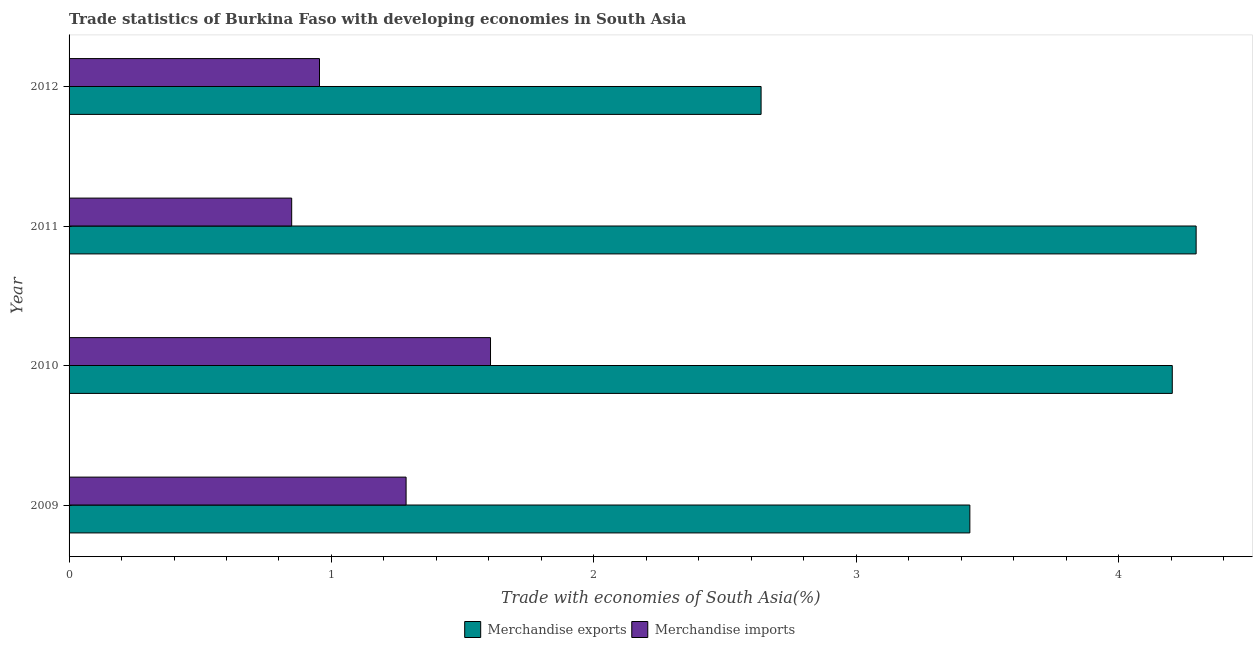How many groups of bars are there?
Offer a very short reply. 4. Are the number of bars per tick equal to the number of legend labels?
Keep it short and to the point. Yes. Are the number of bars on each tick of the Y-axis equal?
Offer a terse response. Yes. How many bars are there on the 1st tick from the top?
Ensure brevity in your answer.  2. What is the label of the 3rd group of bars from the top?
Offer a terse response. 2010. In how many cases, is the number of bars for a given year not equal to the number of legend labels?
Provide a short and direct response. 0. What is the merchandise imports in 2010?
Your answer should be compact. 1.61. Across all years, what is the maximum merchandise exports?
Offer a very short reply. 4.3. Across all years, what is the minimum merchandise imports?
Give a very brief answer. 0.85. In which year was the merchandise exports maximum?
Your answer should be compact. 2011. What is the total merchandise exports in the graph?
Your response must be concise. 14.57. What is the difference between the merchandise imports in 2009 and that in 2010?
Make the answer very short. -0.32. What is the difference between the merchandise imports in 2010 and the merchandise exports in 2011?
Provide a succinct answer. -2.69. What is the average merchandise imports per year?
Make the answer very short. 1.17. In the year 2012, what is the difference between the merchandise imports and merchandise exports?
Provide a succinct answer. -1.68. What is the ratio of the merchandise exports in 2009 to that in 2011?
Ensure brevity in your answer.  0.8. What is the difference between the highest and the second highest merchandise exports?
Your answer should be very brief. 0.09. What is the difference between the highest and the lowest merchandise exports?
Keep it short and to the point. 1.66. In how many years, is the merchandise exports greater than the average merchandise exports taken over all years?
Your answer should be compact. 2. What does the 1st bar from the bottom in 2010 represents?
Ensure brevity in your answer.  Merchandise exports. How many bars are there?
Offer a very short reply. 8. Are all the bars in the graph horizontal?
Make the answer very short. Yes. How many years are there in the graph?
Provide a short and direct response. 4. Does the graph contain any zero values?
Make the answer very short. No. What is the title of the graph?
Provide a succinct answer. Trade statistics of Burkina Faso with developing economies in South Asia. Does "Sanitation services" appear as one of the legend labels in the graph?
Your answer should be very brief. No. What is the label or title of the X-axis?
Provide a succinct answer. Trade with economies of South Asia(%). What is the Trade with economies of South Asia(%) in Merchandise exports in 2009?
Offer a terse response. 3.43. What is the Trade with economies of South Asia(%) of Merchandise imports in 2009?
Your response must be concise. 1.28. What is the Trade with economies of South Asia(%) of Merchandise exports in 2010?
Provide a short and direct response. 4.2. What is the Trade with economies of South Asia(%) of Merchandise imports in 2010?
Offer a very short reply. 1.61. What is the Trade with economies of South Asia(%) in Merchandise exports in 2011?
Provide a succinct answer. 4.3. What is the Trade with economies of South Asia(%) of Merchandise imports in 2011?
Your response must be concise. 0.85. What is the Trade with economies of South Asia(%) of Merchandise exports in 2012?
Ensure brevity in your answer.  2.64. What is the Trade with economies of South Asia(%) in Merchandise imports in 2012?
Keep it short and to the point. 0.95. Across all years, what is the maximum Trade with economies of South Asia(%) in Merchandise exports?
Your answer should be very brief. 4.3. Across all years, what is the maximum Trade with economies of South Asia(%) in Merchandise imports?
Your answer should be compact. 1.61. Across all years, what is the minimum Trade with economies of South Asia(%) of Merchandise exports?
Give a very brief answer. 2.64. Across all years, what is the minimum Trade with economies of South Asia(%) in Merchandise imports?
Offer a terse response. 0.85. What is the total Trade with economies of South Asia(%) in Merchandise exports in the graph?
Give a very brief answer. 14.57. What is the total Trade with economies of South Asia(%) of Merchandise imports in the graph?
Keep it short and to the point. 4.69. What is the difference between the Trade with economies of South Asia(%) in Merchandise exports in 2009 and that in 2010?
Offer a terse response. -0.77. What is the difference between the Trade with economies of South Asia(%) of Merchandise imports in 2009 and that in 2010?
Offer a very short reply. -0.32. What is the difference between the Trade with economies of South Asia(%) of Merchandise exports in 2009 and that in 2011?
Your answer should be very brief. -0.86. What is the difference between the Trade with economies of South Asia(%) of Merchandise imports in 2009 and that in 2011?
Ensure brevity in your answer.  0.44. What is the difference between the Trade with economies of South Asia(%) in Merchandise exports in 2009 and that in 2012?
Ensure brevity in your answer.  0.8. What is the difference between the Trade with economies of South Asia(%) of Merchandise imports in 2009 and that in 2012?
Ensure brevity in your answer.  0.33. What is the difference between the Trade with economies of South Asia(%) of Merchandise exports in 2010 and that in 2011?
Your response must be concise. -0.09. What is the difference between the Trade with economies of South Asia(%) of Merchandise imports in 2010 and that in 2011?
Ensure brevity in your answer.  0.76. What is the difference between the Trade with economies of South Asia(%) in Merchandise exports in 2010 and that in 2012?
Ensure brevity in your answer.  1.57. What is the difference between the Trade with economies of South Asia(%) of Merchandise imports in 2010 and that in 2012?
Ensure brevity in your answer.  0.65. What is the difference between the Trade with economies of South Asia(%) in Merchandise exports in 2011 and that in 2012?
Your answer should be very brief. 1.66. What is the difference between the Trade with economies of South Asia(%) of Merchandise imports in 2011 and that in 2012?
Your response must be concise. -0.11. What is the difference between the Trade with economies of South Asia(%) of Merchandise exports in 2009 and the Trade with economies of South Asia(%) of Merchandise imports in 2010?
Your answer should be very brief. 1.83. What is the difference between the Trade with economies of South Asia(%) in Merchandise exports in 2009 and the Trade with economies of South Asia(%) in Merchandise imports in 2011?
Offer a terse response. 2.58. What is the difference between the Trade with economies of South Asia(%) of Merchandise exports in 2009 and the Trade with economies of South Asia(%) of Merchandise imports in 2012?
Provide a succinct answer. 2.48. What is the difference between the Trade with economies of South Asia(%) in Merchandise exports in 2010 and the Trade with economies of South Asia(%) in Merchandise imports in 2011?
Keep it short and to the point. 3.36. What is the difference between the Trade with economies of South Asia(%) in Merchandise exports in 2010 and the Trade with economies of South Asia(%) in Merchandise imports in 2012?
Keep it short and to the point. 3.25. What is the difference between the Trade with economies of South Asia(%) in Merchandise exports in 2011 and the Trade with economies of South Asia(%) in Merchandise imports in 2012?
Make the answer very short. 3.34. What is the average Trade with economies of South Asia(%) of Merchandise exports per year?
Offer a very short reply. 3.64. What is the average Trade with economies of South Asia(%) of Merchandise imports per year?
Keep it short and to the point. 1.17. In the year 2009, what is the difference between the Trade with economies of South Asia(%) of Merchandise exports and Trade with economies of South Asia(%) of Merchandise imports?
Give a very brief answer. 2.15. In the year 2010, what is the difference between the Trade with economies of South Asia(%) in Merchandise exports and Trade with economies of South Asia(%) in Merchandise imports?
Ensure brevity in your answer.  2.6. In the year 2011, what is the difference between the Trade with economies of South Asia(%) in Merchandise exports and Trade with economies of South Asia(%) in Merchandise imports?
Offer a very short reply. 3.45. In the year 2012, what is the difference between the Trade with economies of South Asia(%) in Merchandise exports and Trade with economies of South Asia(%) in Merchandise imports?
Ensure brevity in your answer.  1.68. What is the ratio of the Trade with economies of South Asia(%) in Merchandise exports in 2009 to that in 2010?
Offer a very short reply. 0.82. What is the ratio of the Trade with economies of South Asia(%) in Merchandise imports in 2009 to that in 2010?
Offer a terse response. 0.8. What is the ratio of the Trade with economies of South Asia(%) in Merchandise exports in 2009 to that in 2011?
Provide a short and direct response. 0.8. What is the ratio of the Trade with economies of South Asia(%) in Merchandise imports in 2009 to that in 2011?
Your response must be concise. 1.51. What is the ratio of the Trade with economies of South Asia(%) of Merchandise exports in 2009 to that in 2012?
Your answer should be very brief. 1.3. What is the ratio of the Trade with economies of South Asia(%) of Merchandise imports in 2009 to that in 2012?
Your answer should be compact. 1.35. What is the ratio of the Trade with economies of South Asia(%) of Merchandise exports in 2010 to that in 2011?
Offer a very short reply. 0.98. What is the ratio of the Trade with economies of South Asia(%) of Merchandise imports in 2010 to that in 2011?
Your response must be concise. 1.89. What is the ratio of the Trade with economies of South Asia(%) of Merchandise exports in 2010 to that in 2012?
Make the answer very short. 1.59. What is the ratio of the Trade with economies of South Asia(%) in Merchandise imports in 2010 to that in 2012?
Ensure brevity in your answer.  1.68. What is the ratio of the Trade with economies of South Asia(%) of Merchandise exports in 2011 to that in 2012?
Ensure brevity in your answer.  1.63. What is the ratio of the Trade with economies of South Asia(%) in Merchandise imports in 2011 to that in 2012?
Offer a terse response. 0.89. What is the difference between the highest and the second highest Trade with economies of South Asia(%) of Merchandise exports?
Your response must be concise. 0.09. What is the difference between the highest and the second highest Trade with economies of South Asia(%) in Merchandise imports?
Your answer should be very brief. 0.32. What is the difference between the highest and the lowest Trade with economies of South Asia(%) of Merchandise exports?
Your answer should be very brief. 1.66. What is the difference between the highest and the lowest Trade with economies of South Asia(%) of Merchandise imports?
Give a very brief answer. 0.76. 